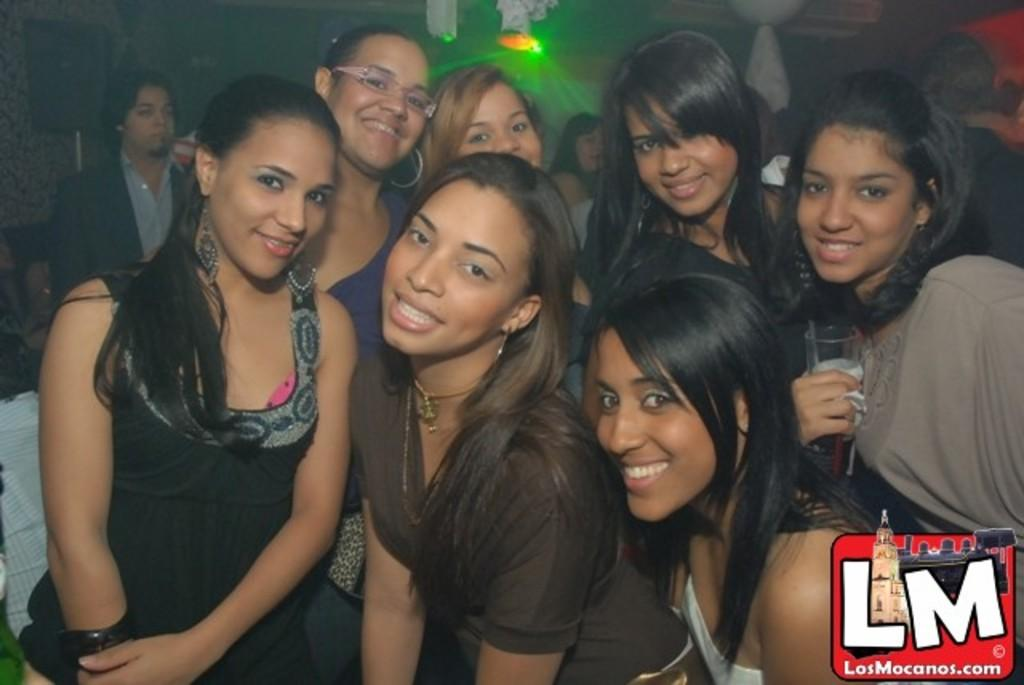How many women are present in the image? There are multiple women in the image. Can you describe the person in the background of the image? There is a person standing in the background of the image. What colors can be seen in the background of the image? There are white and red colored objects in the background of the image. What can be seen illuminated in the background of the image? There are lights visible in the background of the image. What type of instrument is being played by the women in the image? There is no instrument being played by the women in the image. Can you describe the houses visible in the image? There are no houses visible in the image. 